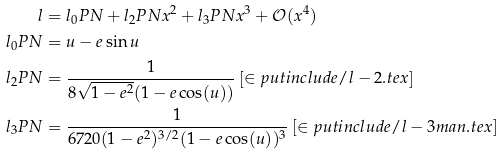<formula> <loc_0><loc_0><loc_500><loc_500>l & = l _ { 0 } P N + l _ { 2 } P N x ^ { 2 } + l _ { 3 } P N x ^ { 3 } + \mathcal { O } ( x ^ { 4 } ) \\ l _ { 0 } P N & = u - e \sin u \\ l _ { 2 } P N & = \frac { 1 } { 8 \sqrt { 1 - e ^ { 2 } } ( 1 - e \cos ( u ) ) } \left [ \in p u t { i n c l u d e / l - 2 . t e x } \right ] \\ l _ { 3 } P N & = \frac { 1 } { 6 7 2 0 ( 1 - e ^ { 2 } ) ^ { 3 / 2 } ( 1 - e \cos ( u ) ) ^ { 3 } } \left [ \in p u t { i n c l u d e / l - 3 m a n . t e x } \right ]</formula> 